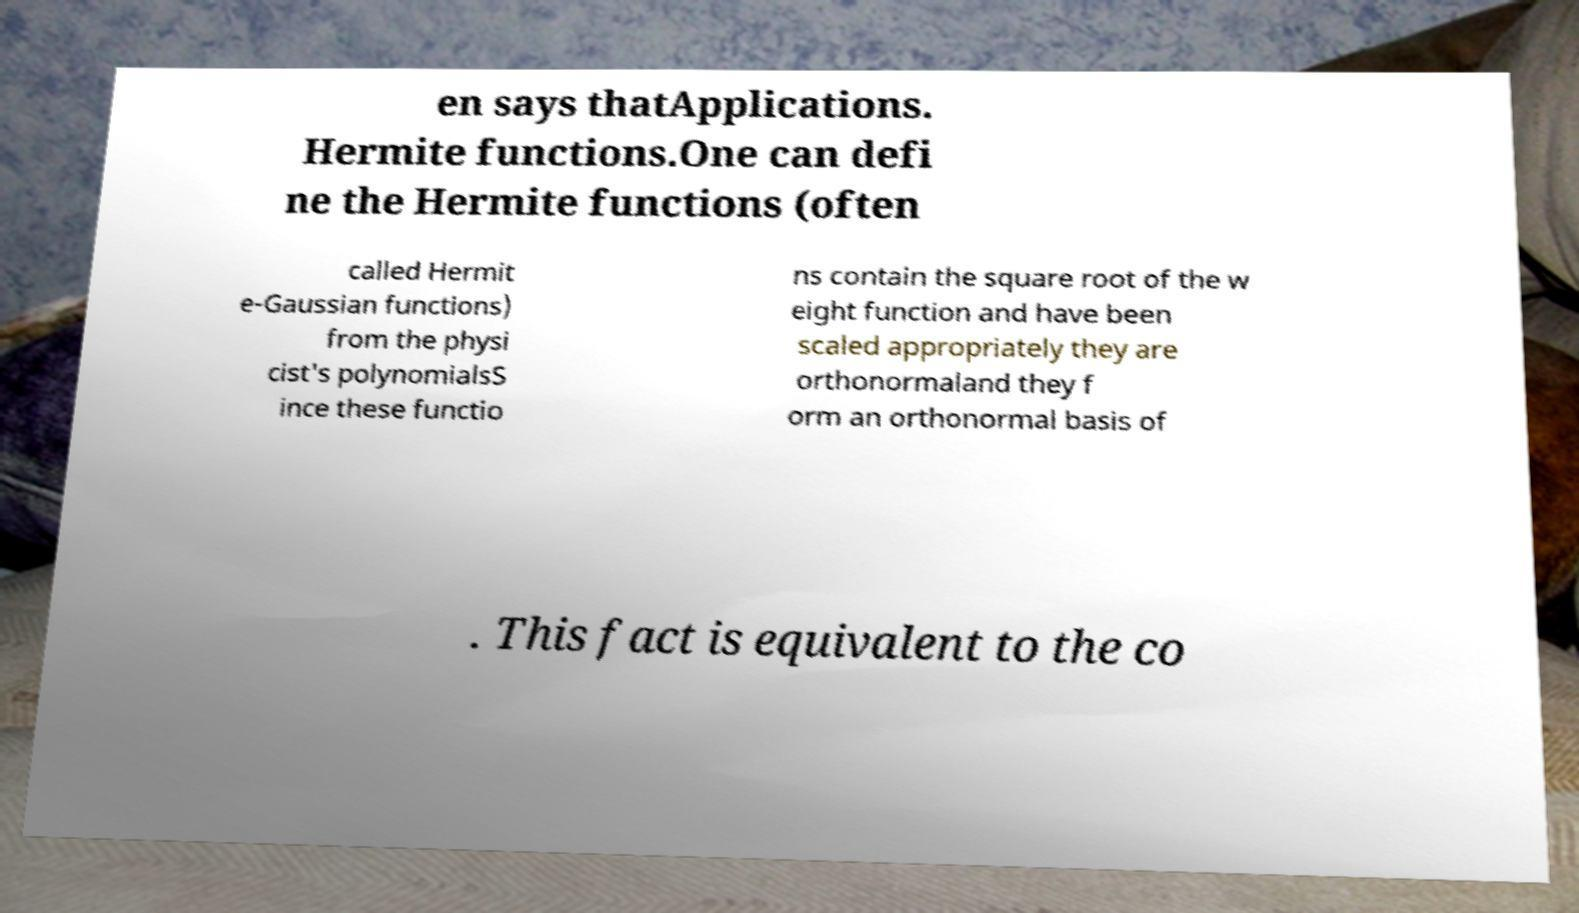For documentation purposes, I need the text within this image transcribed. Could you provide that? en says thatApplications. Hermite functions.One can defi ne the Hermite functions (often called Hermit e-Gaussian functions) from the physi cist's polynomialsS ince these functio ns contain the square root of the w eight function and have been scaled appropriately they are orthonormaland they f orm an orthonormal basis of . This fact is equivalent to the co 